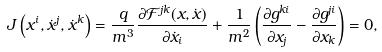Convert formula to latex. <formula><loc_0><loc_0><loc_500><loc_500>J \left ( x ^ { i } , \dot { x } ^ { j } , \dot { x } ^ { k } \right ) = \frac { q } { m ^ { 3 } } \frac { \partial { \mathcal { F } } ^ { j k } ( x , \dot { x } ) } { \partial \dot { x } _ { i } } + \frac { 1 } { m ^ { 2 } } \left ( \frac { \partial g ^ { k i } } { \partial x _ { j } } - \frac { \partial g ^ { j i } } { \partial x _ { k } } \right ) = 0 ,</formula> 